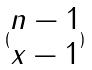Convert formula to latex. <formula><loc_0><loc_0><loc_500><loc_500>( \begin{matrix} n - 1 \\ x - 1 \end{matrix} )</formula> 